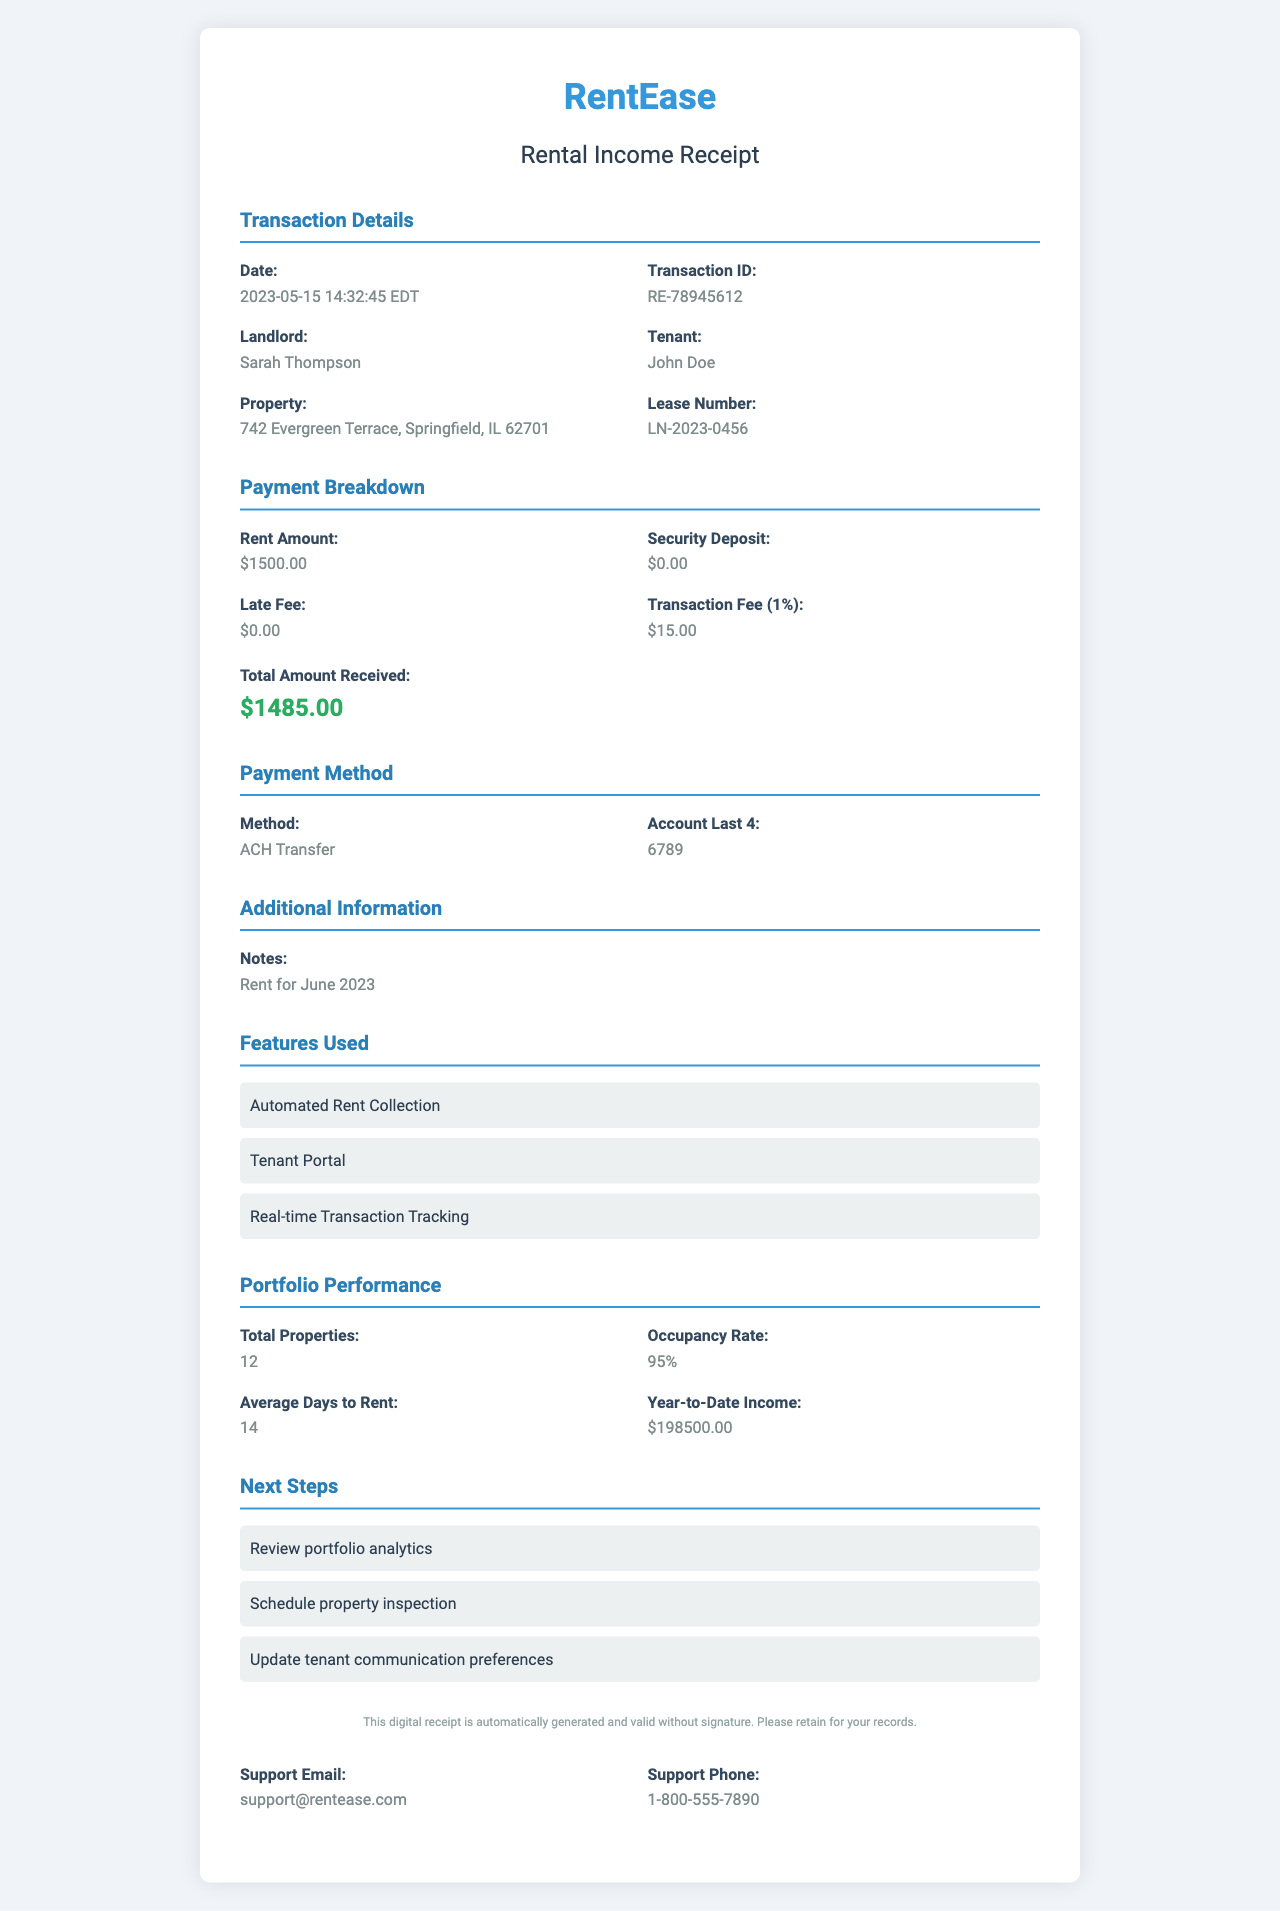What is the platform name? The platform name is prominently displayed at the top of the document.
Answer: RentEase What is the rent amount? The rent amount is stated under the payment breakdown section in the document.
Answer: $1500.00 Who is the tenant? The name of the tenant is clearly listed in the transaction details section.
Answer: John Doe What is the transaction fee? The transaction fee is detailed as a separate item in the payment breakdown section.
Answer: $15.00 What was the total amount received? The total amount received is shown as the final value in the payment breakdown section.
Answer: $1485.00 What is the occupancy rate of the portfolio? The occupancy rate is listed under the portfolio performance section in the document.
Answer: 95% How many properties are included in the portfolio? The total number of properties is mentioned in the portfolio performance section.
Answer: 12 What is the transaction time? The transaction time is included in the transaction details section of the document.
Answer: 14:32:45 EDT What method was used for the payment? The payment method is specified in the payment method section of the document.
Answer: ACH Transfer 